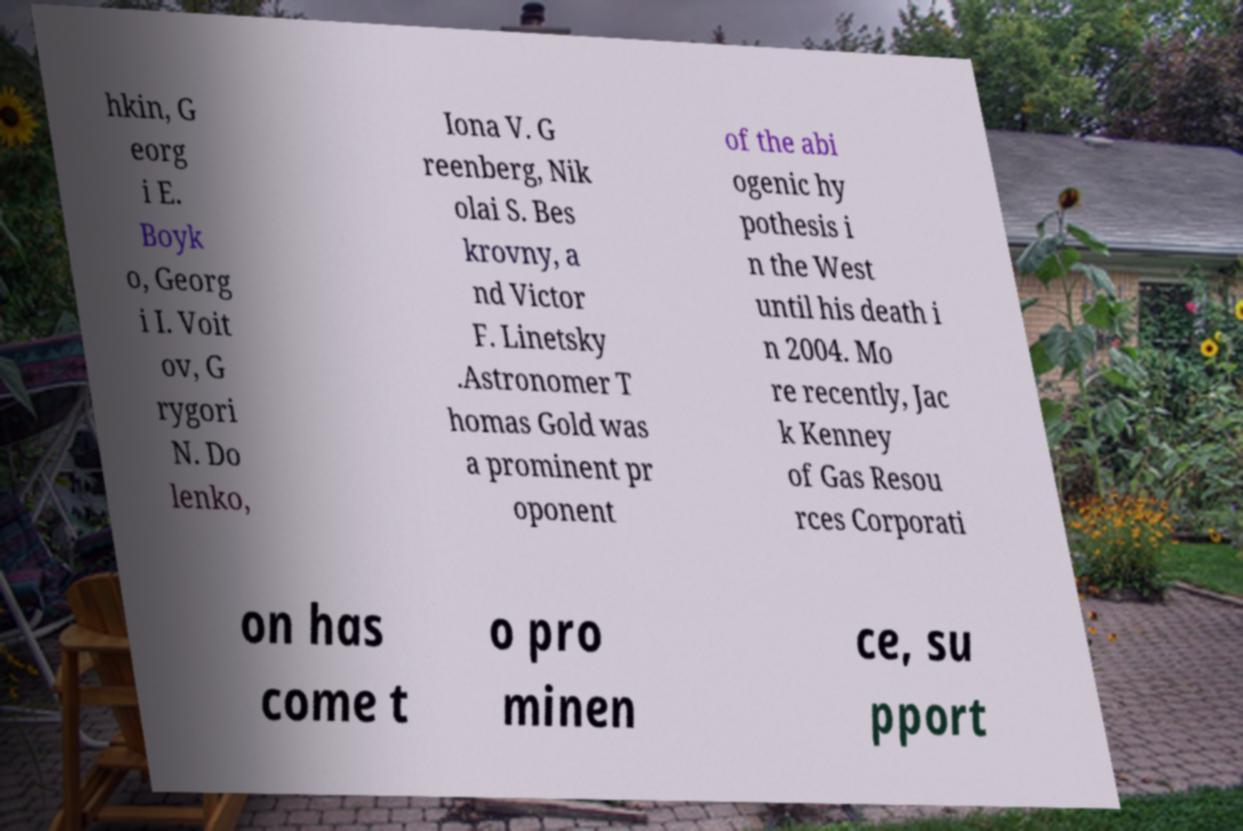There's text embedded in this image that I need extracted. Can you transcribe it verbatim? hkin, G eorg i E. Boyk o, Georg i I. Voit ov, G rygori N. Do lenko, Iona V. G reenberg, Nik olai S. Bes krovny, a nd Victor F. Linetsky .Astronomer T homas Gold was a prominent pr oponent of the abi ogenic hy pothesis i n the West until his death i n 2004. Mo re recently, Jac k Kenney of Gas Resou rces Corporati on has come t o pro minen ce, su pport 